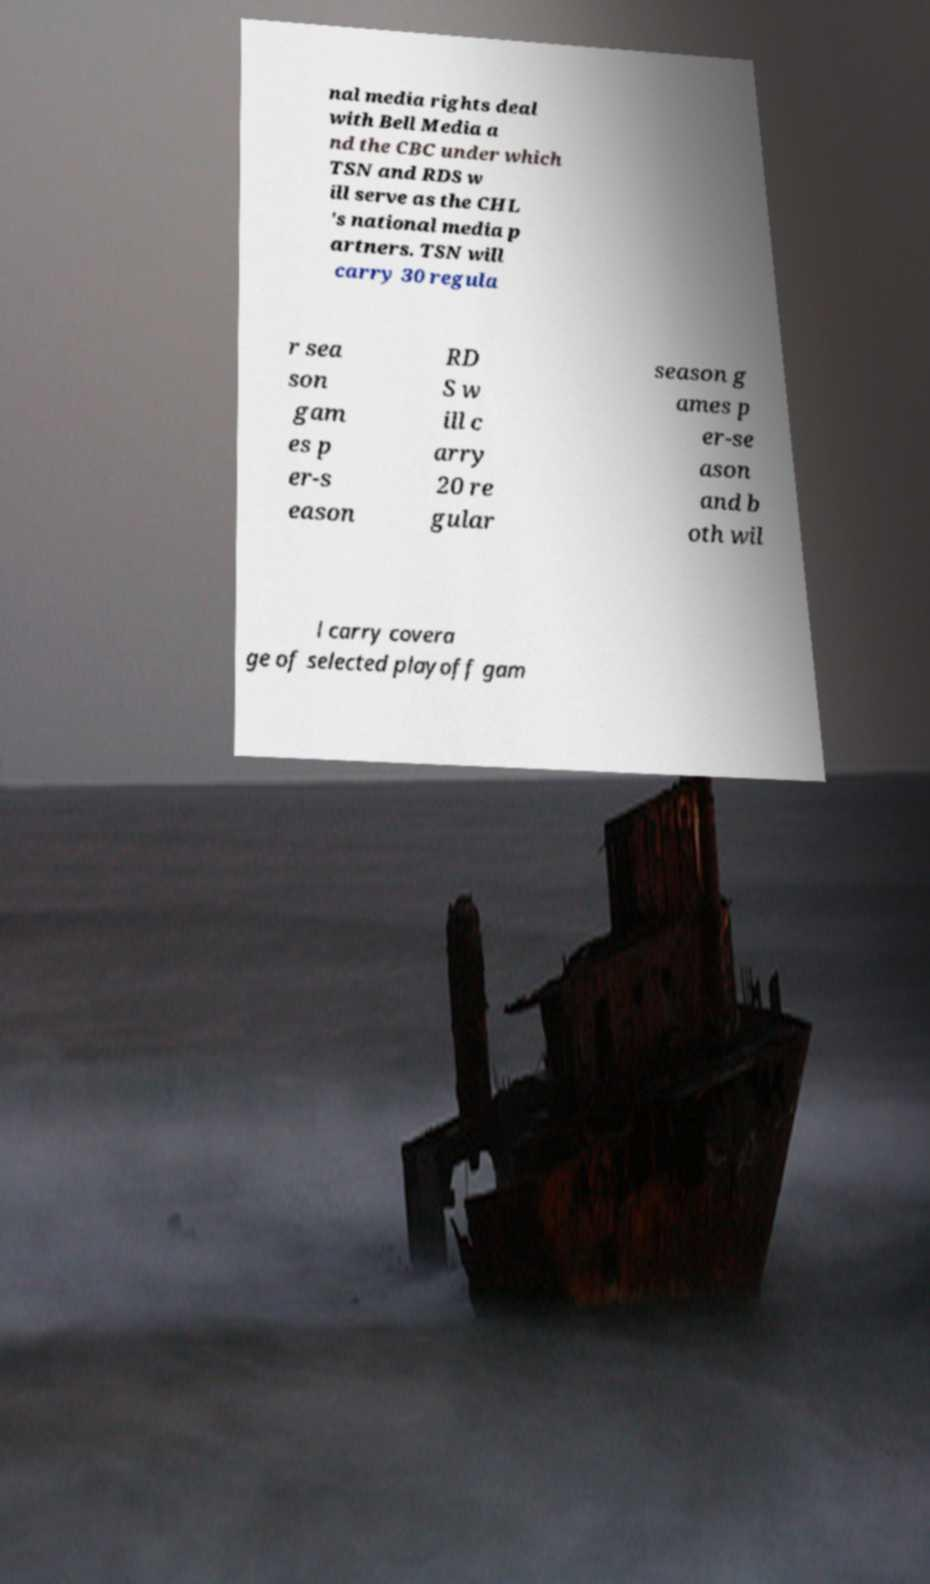Can you read and provide the text displayed in the image?This photo seems to have some interesting text. Can you extract and type it out for me? nal media rights deal with Bell Media a nd the CBC under which TSN and RDS w ill serve as the CHL 's national media p artners. TSN will carry 30 regula r sea son gam es p er-s eason RD S w ill c arry 20 re gular season g ames p er-se ason and b oth wil l carry covera ge of selected playoff gam 